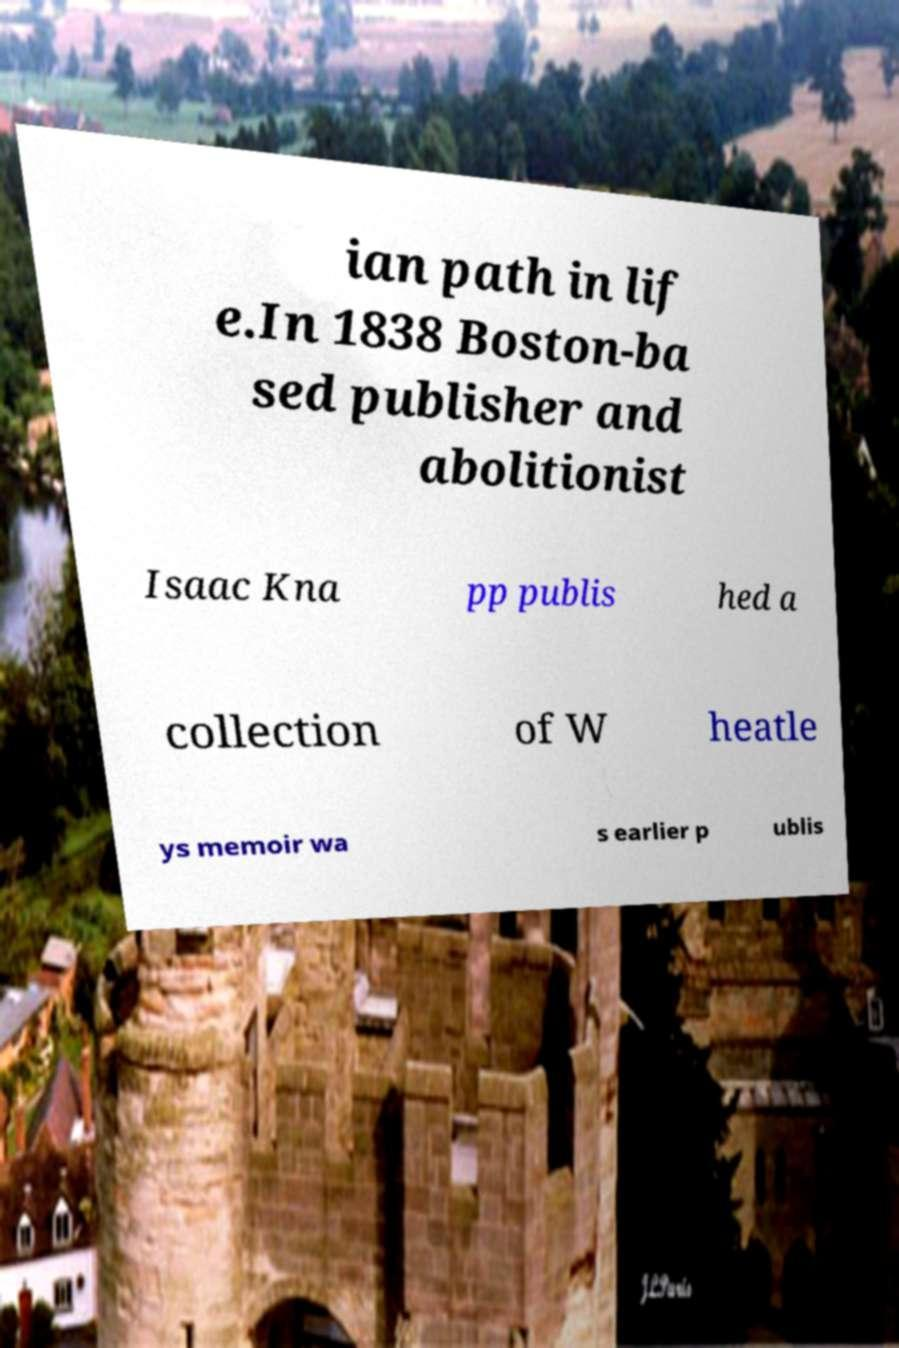For documentation purposes, I need the text within this image transcribed. Could you provide that? ian path in lif e.In 1838 Boston-ba sed publisher and abolitionist Isaac Kna pp publis hed a collection of W heatle ys memoir wa s earlier p ublis 